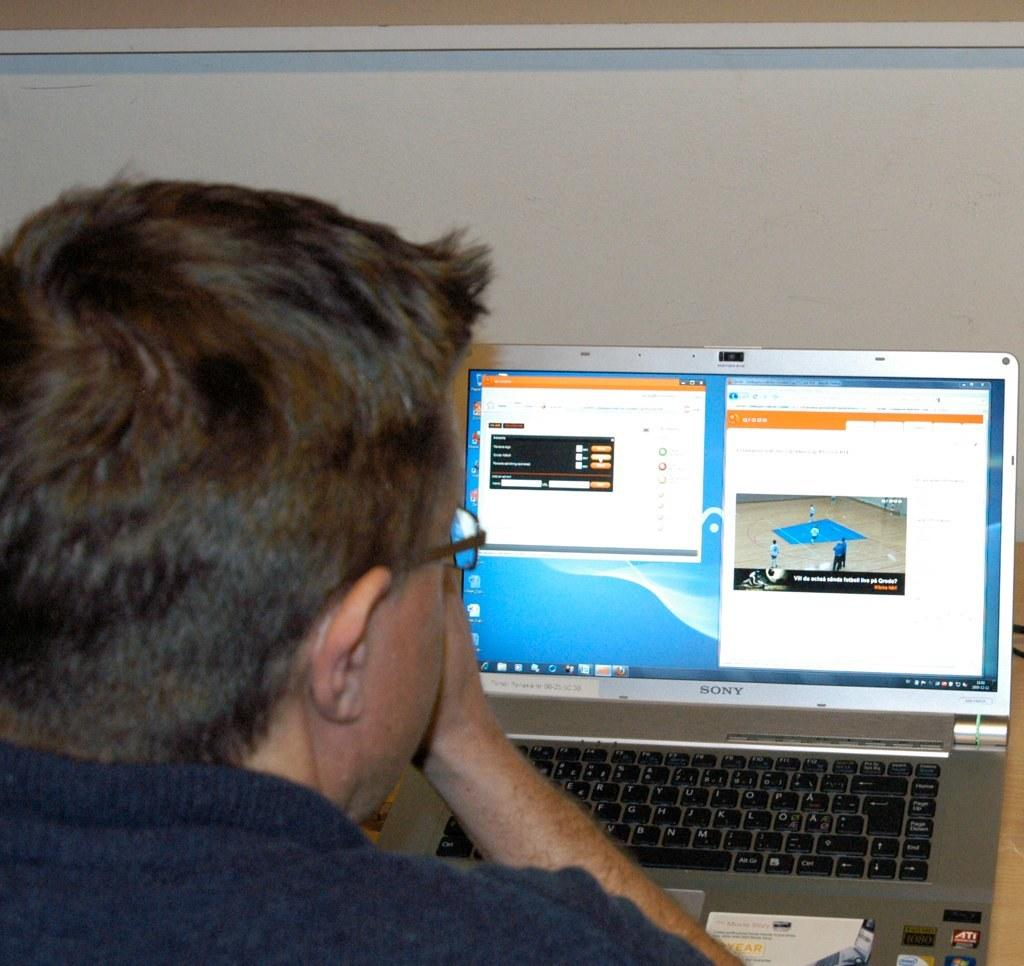<image>
Write a terse but informative summary of the picture. An open laptop that has "Sony" written under the monitor. 